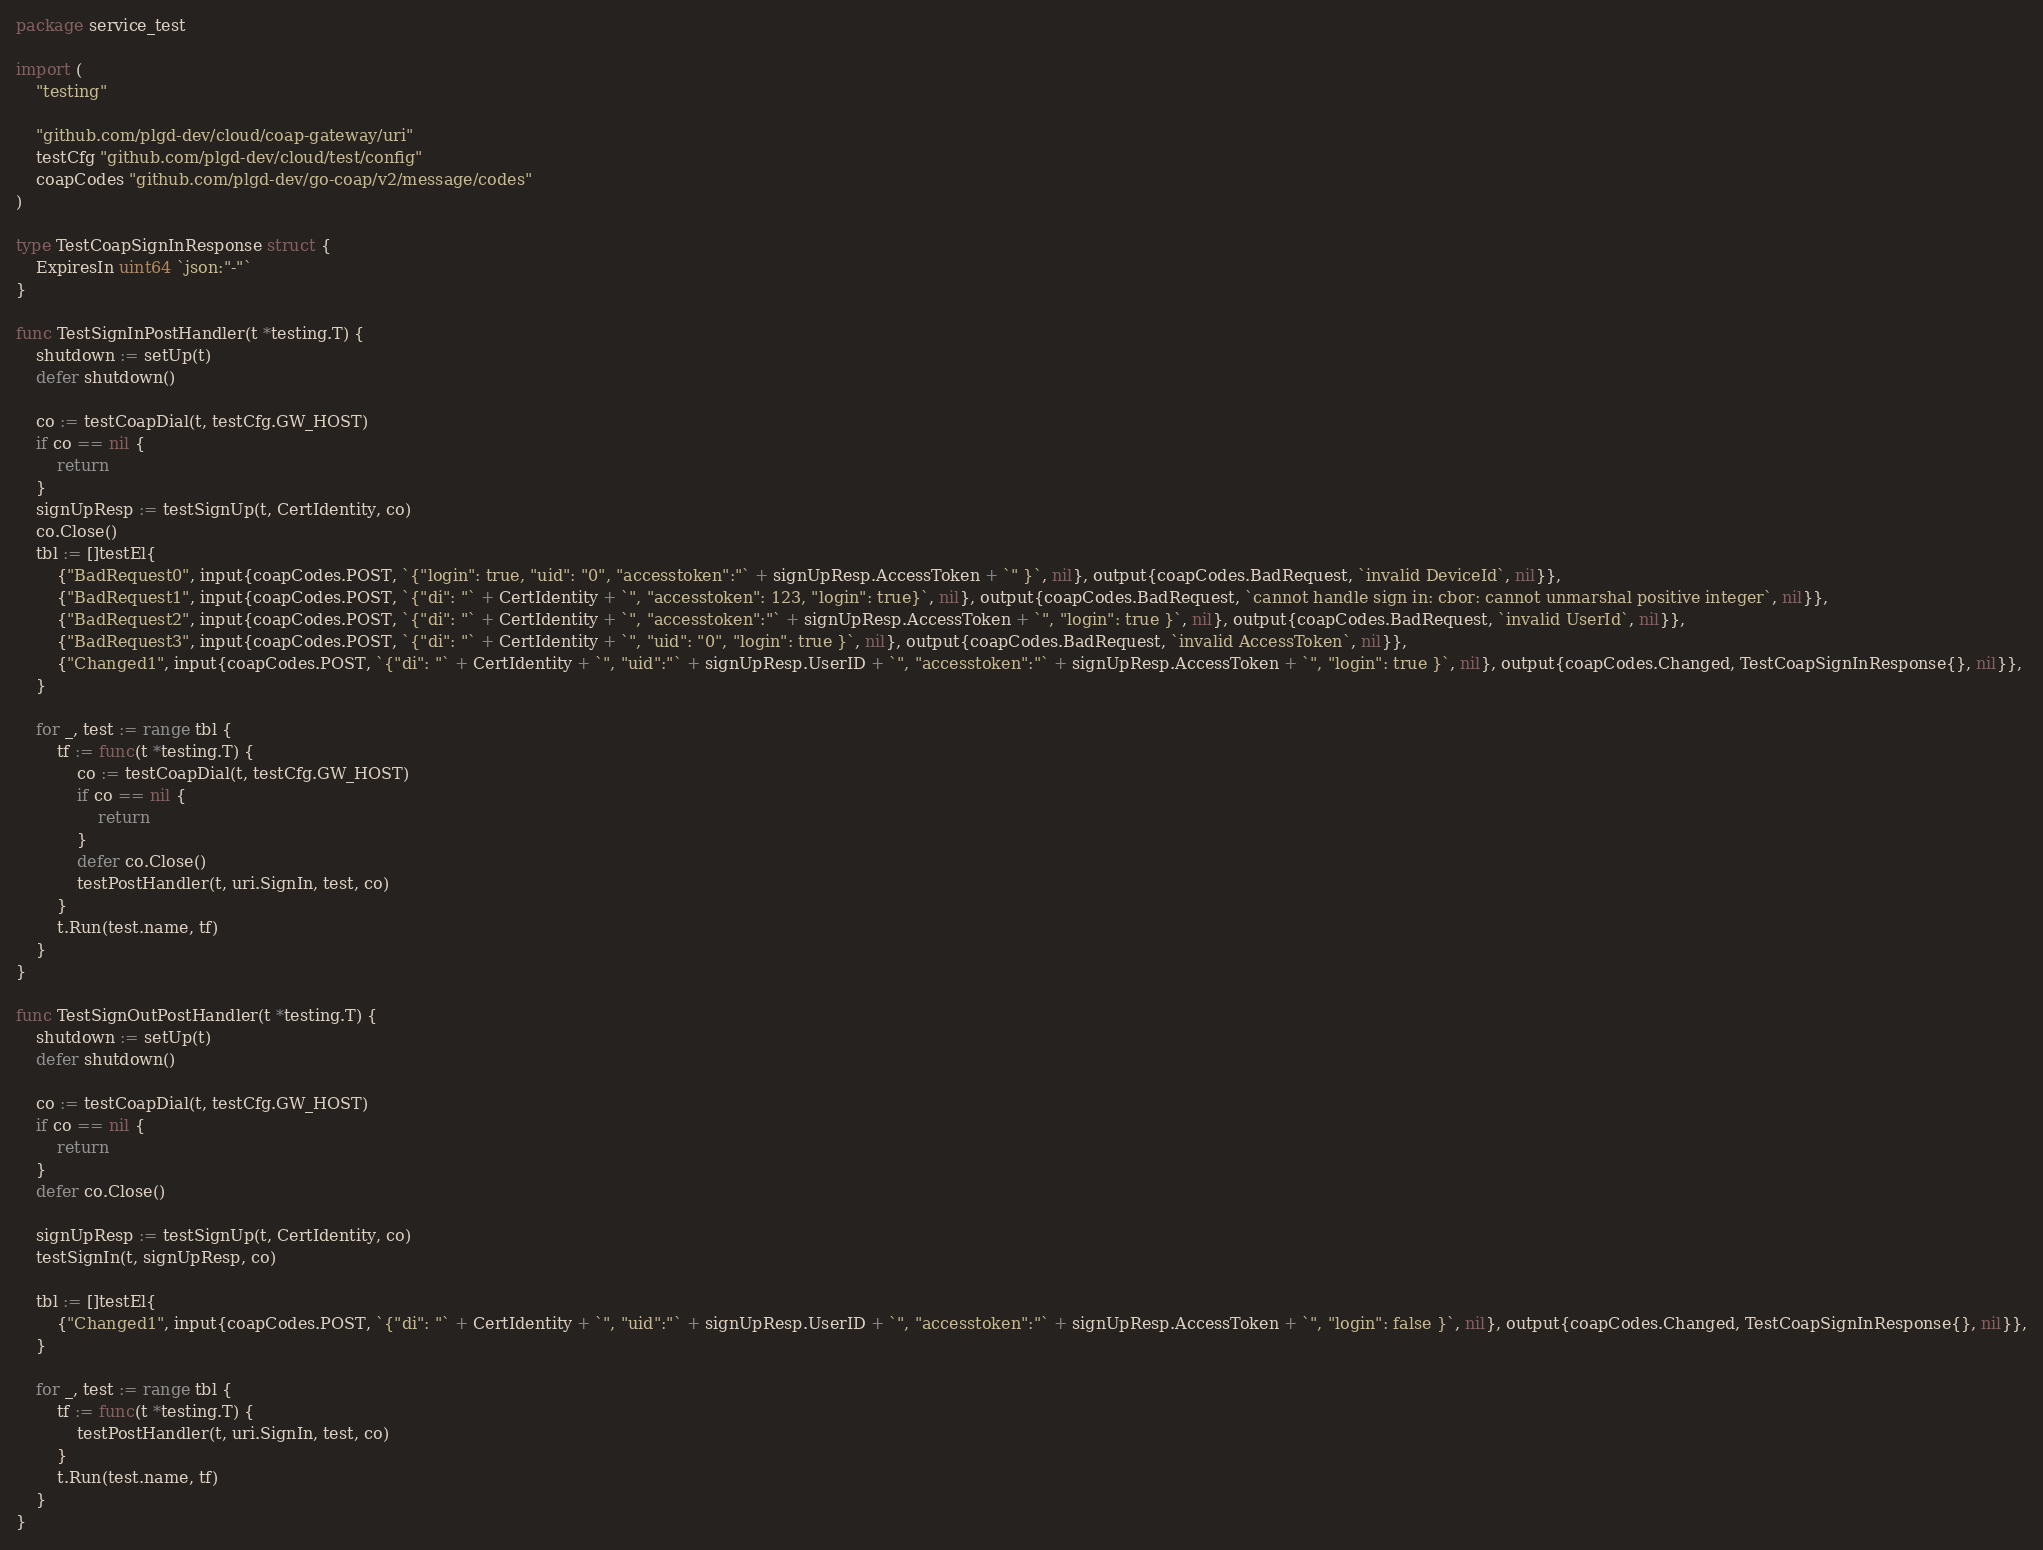<code> <loc_0><loc_0><loc_500><loc_500><_Go_>package service_test

import (
	"testing"

	"github.com/plgd-dev/cloud/coap-gateway/uri"
	testCfg "github.com/plgd-dev/cloud/test/config"
	coapCodes "github.com/plgd-dev/go-coap/v2/message/codes"
)

type TestCoapSignInResponse struct {
	ExpiresIn uint64 `json:"-"`
}

func TestSignInPostHandler(t *testing.T) {
	shutdown := setUp(t)
	defer shutdown()

	co := testCoapDial(t, testCfg.GW_HOST)
	if co == nil {
		return
	}
	signUpResp := testSignUp(t, CertIdentity, co)
	co.Close()
	tbl := []testEl{
		{"BadRequest0", input{coapCodes.POST, `{"login": true, "uid": "0", "accesstoken":"` + signUpResp.AccessToken + `" }`, nil}, output{coapCodes.BadRequest, `invalid DeviceId`, nil}},
		{"BadRequest1", input{coapCodes.POST, `{"di": "` + CertIdentity + `", "accesstoken": 123, "login": true}`, nil}, output{coapCodes.BadRequest, `cannot handle sign in: cbor: cannot unmarshal positive integer`, nil}},
		{"BadRequest2", input{coapCodes.POST, `{"di": "` + CertIdentity + `", "accesstoken":"` + signUpResp.AccessToken + `", "login": true }`, nil}, output{coapCodes.BadRequest, `invalid UserId`, nil}},
		{"BadRequest3", input{coapCodes.POST, `{"di": "` + CertIdentity + `", "uid": "0", "login": true }`, nil}, output{coapCodes.BadRequest, `invalid AccessToken`, nil}},
		{"Changed1", input{coapCodes.POST, `{"di": "` + CertIdentity + `", "uid":"` + signUpResp.UserID + `", "accesstoken":"` + signUpResp.AccessToken + `", "login": true }`, nil}, output{coapCodes.Changed, TestCoapSignInResponse{}, nil}},
	}

	for _, test := range tbl {
		tf := func(t *testing.T) {
			co := testCoapDial(t, testCfg.GW_HOST)
			if co == nil {
				return
			}
			defer co.Close()
			testPostHandler(t, uri.SignIn, test, co)
		}
		t.Run(test.name, tf)
	}
}

func TestSignOutPostHandler(t *testing.T) {
	shutdown := setUp(t)
	defer shutdown()

	co := testCoapDial(t, testCfg.GW_HOST)
	if co == nil {
		return
	}
	defer co.Close()

	signUpResp := testSignUp(t, CertIdentity, co)
	testSignIn(t, signUpResp, co)

	tbl := []testEl{
		{"Changed1", input{coapCodes.POST, `{"di": "` + CertIdentity + `", "uid":"` + signUpResp.UserID + `", "accesstoken":"` + signUpResp.AccessToken + `", "login": false }`, nil}, output{coapCodes.Changed, TestCoapSignInResponse{}, nil}},
	}

	for _, test := range tbl {
		tf := func(t *testing.T) {
			testPostHandler(t, uri.SignIn, test, co)
		}
		t.Run(test.name, tf)
	}
}
</code> 